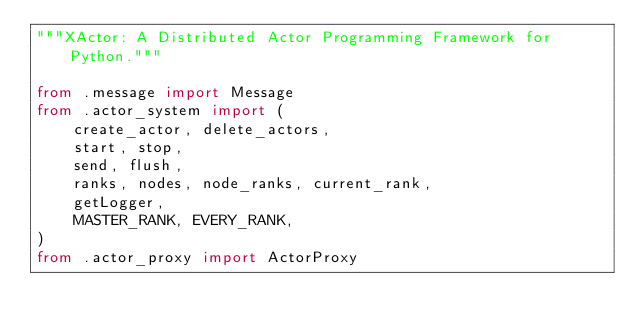Convert code to text. <code><loc_0><loc_0><loc_500><loc_500><_Python_>"""XActor: A Distributed Actor Programming Framework for Python."""

from .message import Message
from .actor_system import (
    create_actor, delete_actors,
    start, stop,
    send, flush,
    ranks, nodes, node_ranks, current_rank,
    getLogger,
    MASTER_RANK, EVERY_RANK,
)
from .actor_proxy import ActorProxy
</code> 